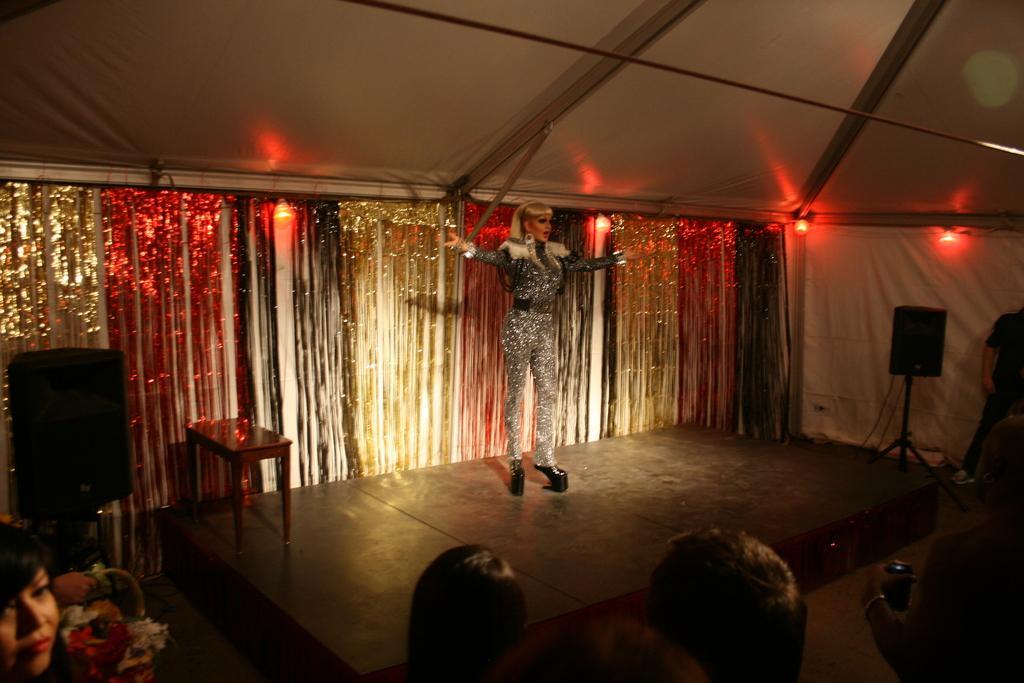In one or two sentences, can you explain what this image depicts? In this image a woman is standing on the stage having a table and a sound speaker is attached to the stand. Bottom of image there are few persons. A person is holding a coke can in his hand. A person is holding a basket having few flowers in it. Few lamps are attached to the wall. Left side there is a sound speaker on the stand. 